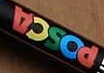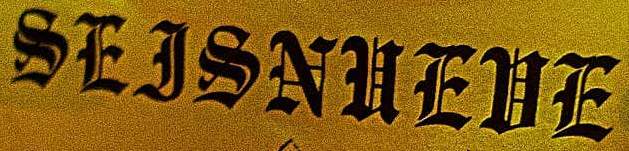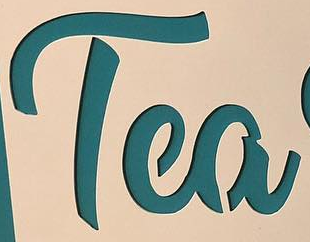Read the text from these images in sequence, separated by a semicolon. POSCA; SEJSNUEUE; Tea 